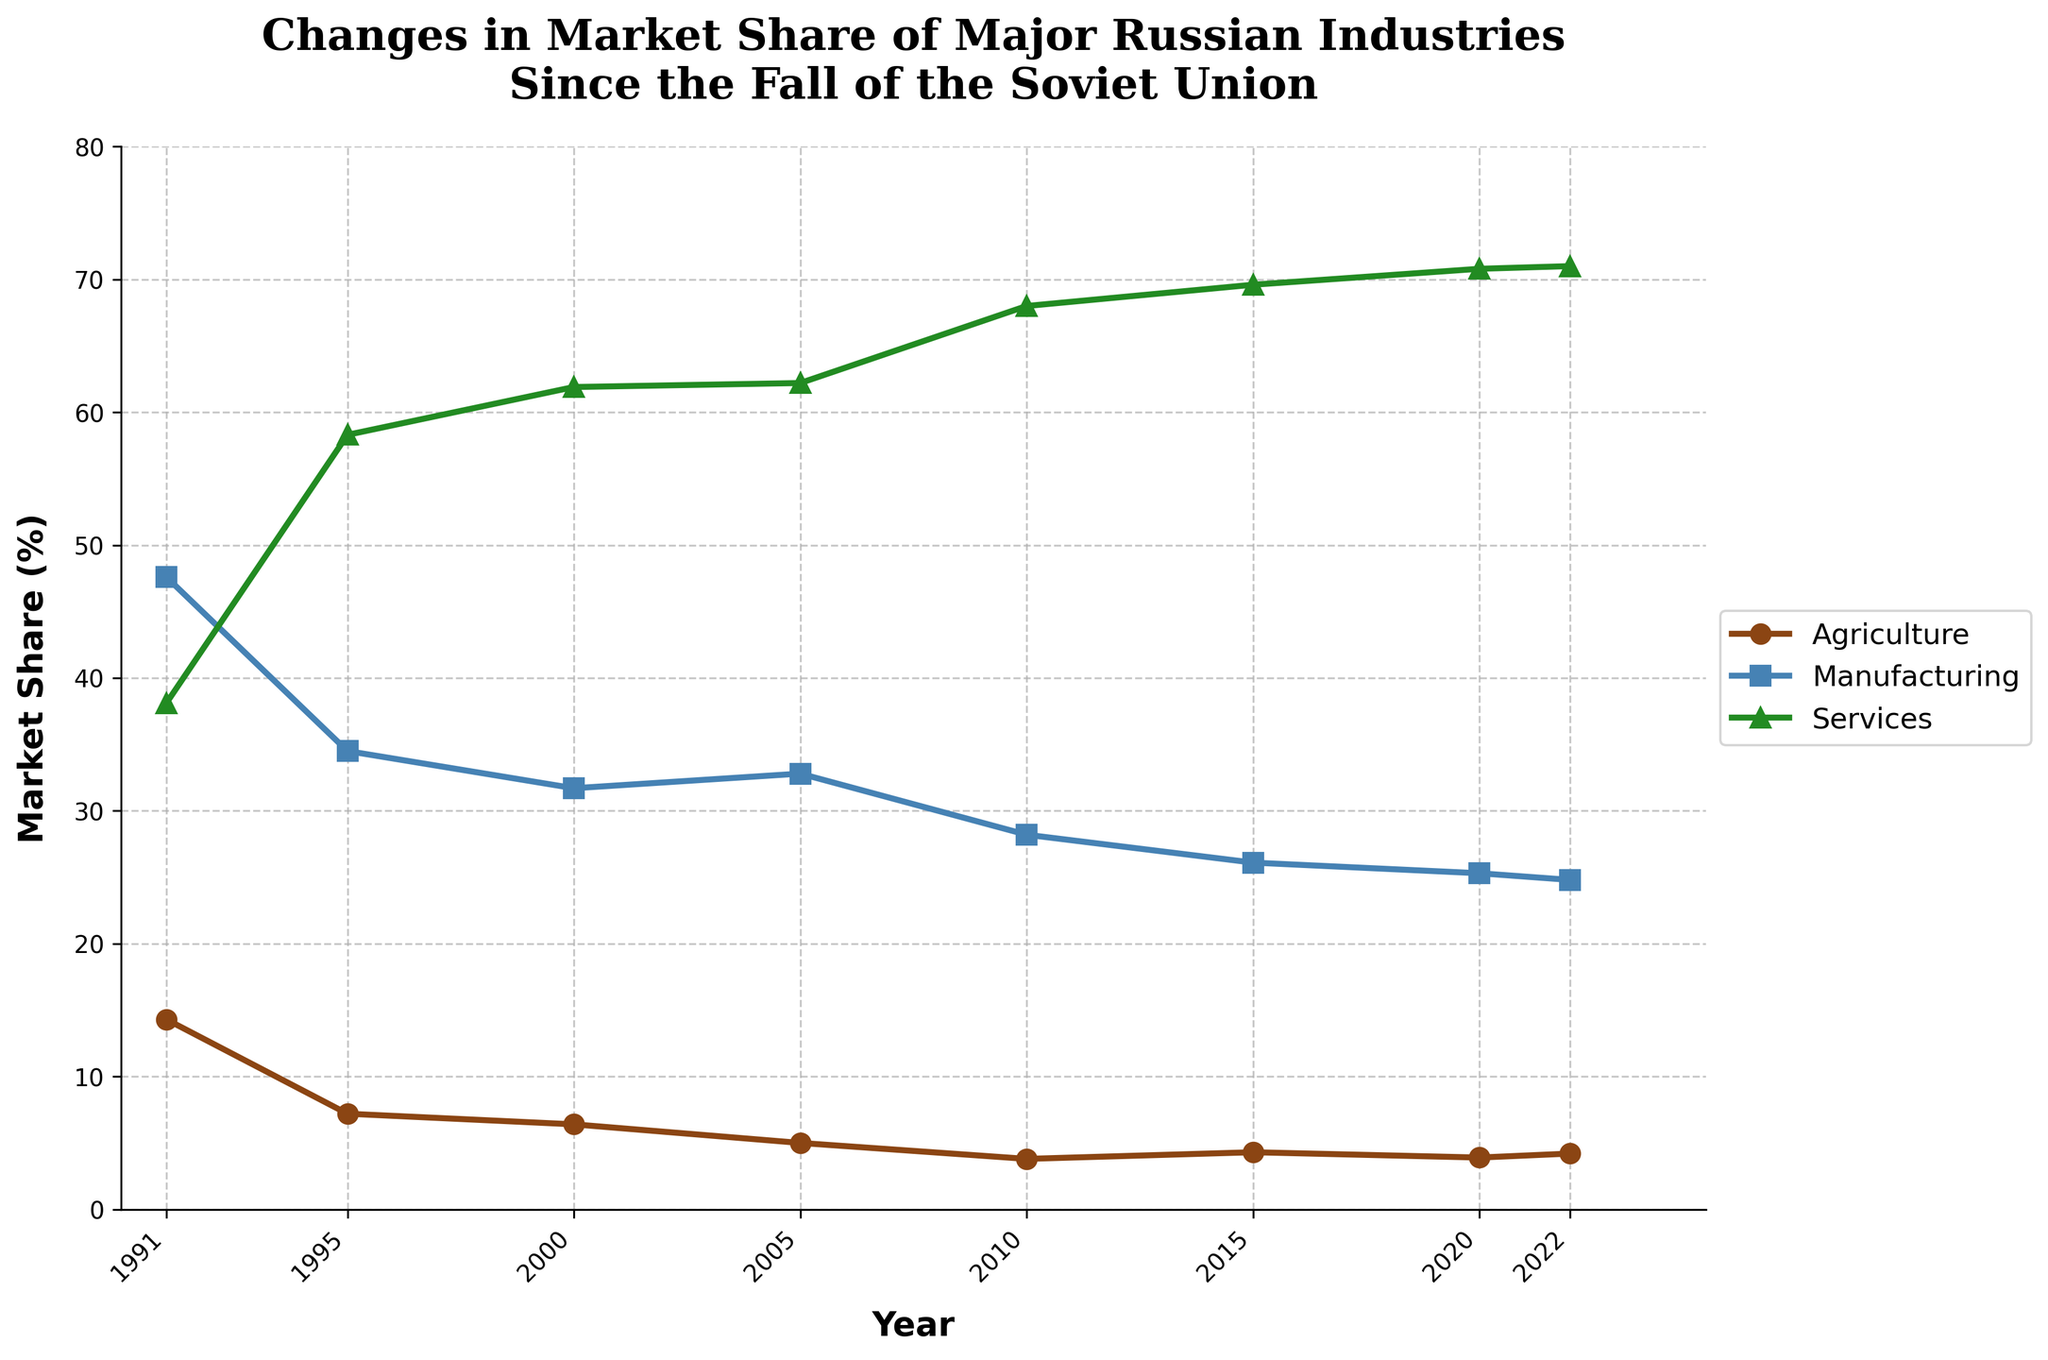What trend can be observed in the market share of the services industry from 1991 to 2022? The market share of the services industry shows a steady increase from 38.1% in 1991 to 71.0% in 2022, indicating growth in this sector over the years.
Answer: Steady increase Which industry had the highest market share in 1991? By looking at the data for 1991, the manufacturing industry had the highest market share at 47.6%.
Answer: Manufacturing How much did the market share of agriculture decrease between 1991 and 2000? The market share of agriculture was 14.3% in 1991 and dropped to 6.4% in 2000. The decrease is calculated as 14.3% - 6.4% = 7.9%.
Answer: 7.9% Between which years did manufacturing see the largest drop in market share? The largest drop in manufacturing market share occurred between 1991 and 1995, where it fell from 47.6% to 34.5%, a decrease of 13.1%.
Answer: 1991 and 1995 From the data, which year marks the first time the services industry reaches a market share above 60%? Observing the data, the services industry first surpasses 60% market share in the year 2000, with 61.9%.
Answer: 2000 How does the market share change from 2010 to 2022 in agriculture compare to the change in manufacturing? Between 2010 and 2022, the market share of agriculture slightly increases from 3.8% to 4.2%, a change of +0.4%. In the same period, manufacturing decreases from 28.2% to 24.8%, a change of -3.4%.
Answer: Agriculture: +0.4%, Manufacturing: -3.4% Which industry showed the least fluctuation in market share from 1991 to 2022? By examining the trends, manufacturing shows significant decreases, while services show increases. Agriculture has fluctuations but remains relatively stable within the range of 3.8% to 7.2%.
Answer: Agriculture If you sum the market share percentages for all three industries in the year 2020, what do you get? The sum of the market share for agriculture (3.9%), manufacturing (25.3%), and services (70.8%) in 2020 is 3.9 + 25.3 + 70.8 = 100.0%.
Answer: 100.0% From 1991 to 2022, which industry showed a general declining trend? By observing the trends over the years, the manufacturing industry shows a general declining trend, dropping from 47.6% in 1991 to 24.8% in 2022.
Answer: Manufacturing Between which consecutive years did agriculture experience the highest percentage increase? Between 2010 and 2015, agriculture's market share increased from 3.8% to 4.3%, which is a percentage increase of (4.3 - 3.8) / 3.8 * 100 = 13.16%.
Answer: 2010 and 2015 